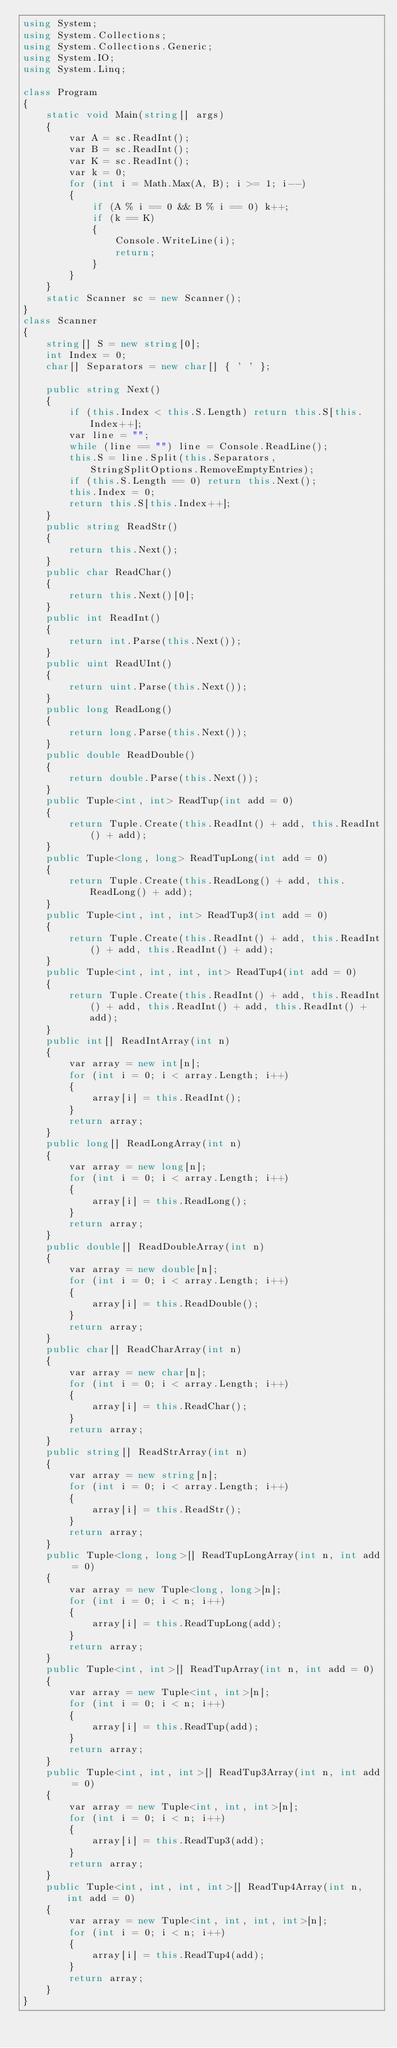<code> <loc_0><loc_0><loc_500><loc_500><_C#_>using System;
using System.Collections;
using System.Collections.Generic;
using System.IO;
using System.Linq;

class Program
{
    static void Main(string[] args)
    {
        var A = sc.ReadInt();
        var B = sc.ReadInt();
        var K = sc.ReadInt();
        var k = 0;
        for (int i = Math.Max(A, B); i >= 1; i--)
        {
            if (A % i == 0 && B % i == 0) k++;
            if (k == K)
            {
                Console.WriteLine(i);
                return;
            }
        }
    }
    static Scanner sc = new Scanner();
}
class Scanner
{
    string[] S = new string[0];
    int Index = 0;
    char[] Separators = new char[] { ' ' };

    public string Next()
    {
        if (this.Index < this.S.Length) return this.S[this.Index++];
        var line = "";
        while (line == "") line = Console.ReadLine();
        this.S = line.Split(this.Separators, StringSplitOptions.RemoveEmptyEntries);
        if (this.S.Length == 0) return this.Next();
        this.Index = 0;
        return this.S[this.Index++];
    }
    public string ReadStr()
    {
        return this.Next();
    }
    public char ReadChar()
    {
        return this.Next()[0];
    }
    public int ReadInt()
    {
        return int.Parse(this.Next());
    }
    public uint ReadUInt()
    {
        return uint.Parse(this.Next());
    }
    public long ReadLong()
    {
        return long.Parse(this.Next());
    }
    public double ReadDouble()
    {
        return double.Parse(this.Next());
    }
    public Tuple<int, int> ReadTup(int add = 0)
    {
        return Tuple.Create(this.ReadInt() + add, this.ReadInt() + add);
    }
    public Tuple<long, long> ReadTupLong(int add = 0)
    {
        return Tuple.Create(this.ReadLong() + add, this.ReadLong() + add);
    }
    public Tuple<int, int, int> ReadTup3(int add = 0)
    {
        return Tuple.Create(this.ReadInt() + add, this.ReadInt() + add, this.ReadInt() + add);
    }
    public Tuple<int, int, int, int> ReadTup4(int add = 0)
    {
        return Tuple.Create(this.ReadInt() + add, this.ReadInt() + add, this.ReadInt() + add, this.ReadInt() + add);
    }
    public int[] ReadIntArray(int n)
    {
        var array = new int[n];
        for (int i = 0; i < array.Length; i++)
        {
            array[i] = this.ReadInt();
        }
        return array;
    }
    public long[] ReadLongArray(int n)
    {
        var array = new long[n];
        for (int i = 0; i < array.Length; i++)
        {
            array[i] = this.ReadLong();
        }
        return array;
    }
    public double[] ReadDoubleArray(int n)
    {
        var array = new double[n];
        for (int i = 0; i < array.Length; i++)
        {
            array[i] = this.ReadDouble();
        }
        return array;
    }
    public char[] ReadCharArray(int n)
    {
        var array = new char[n];
        for (int i = 0; i < array.Length; i++)
        {
            array[i] = this.ReadChar();
        }
        return array;
    }
    public string[] ReadStrArray(int n)
    {
        var array = new string[n];
        for (int i = 0; i < array.Length; i++)
        {
            array[i] = this.ReadStr();
        }
        return array;
    }
    public Tuple<long, long>[] ReadTupLongArray(int n, int add = 0)
    {
        var array = new Tuple<long, long>[n];
        for (int i = 0; i < n; i++)
        {
            array[i] = this.ReadTupLong(add);
        }
        return array;
    }
    public Tuple<int, int>[] ReadTupArray(int n, int add = 0)
    {
        var array = new Tuple<int, int>[n];
        for (int i = 0; i < n; i++)
        {
            array[i] = this.ReadTup(add);
        }
        return array;
    }
    public Tuple<int, int, int>[] ReadTup3Array(int n, int add = 0)
    {
        var array = new Tuple<int, int, int>[n];
        for (int i = 0; i < n; i++)
        {
            array[i] = this.ReadTup3(add);
        }
        return array;
    }
    public Tuple<int, int, int, int>[] ReadTup4Array(int n, int add = 0)
    {
        var array = new Tuple<int, int, int, int>[n];
        for (int i = 0; i < n; i++)
        {
            array[i] = this.ReadTup4(add);
        }
        return array;
    }
}
</code> 